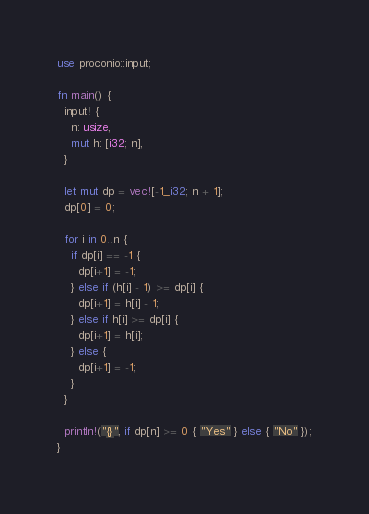<code> <loc_0><loc_0><loc_500><loc_500><_Rust_>use proconio::input;

fn main() {
  input! {
    n: usize,
    mut h: [i32; n],
  }

  let mut dp = vec![-1_i32; n + 1];
  dp[0] = 0;

  for i in 0..n {
    if dp[i] == -1 {
      dp[i+1] = -1;
    } else if (h[i] - 1) >= dp[i] {
      dp[i+1] = h[i] - 1;
    } else if h[i] >= dp[i] {
      dp[i+1] = h[i];
    } else {
      dp[i+1] = -1;
    }
  }

  println!("{}", if dp[n] >= 0 { "Yes" } else { "No" });
}
</code> 